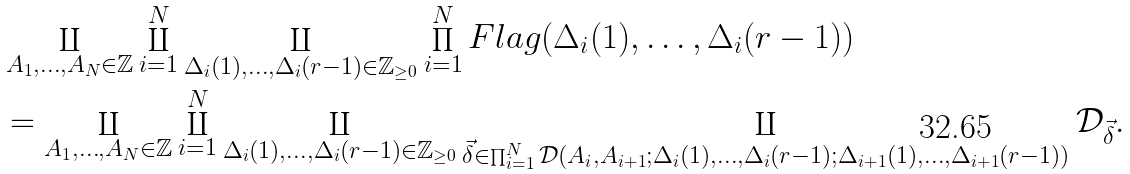<formula> <loc_0><loc_0><loc_500><loc_500>& \coprod _ { A _ { 1 } , \dots , A _ { N } \in \mathbb { Z } } \coprod _ { i = 1 } ^ { N } \coprod _ { \Delta _ { i } ( 1 ) , \dots , \Delta _ { i } ( r - 1 ) \in \mathbb { Z } _ { \geq 0 } } \prod _ { i = 1 } ^ { N } F l a g ( \Delta _ { i } ( 1 ) , \dots , \Delta _ { i } ( r - 1 ) ) \\ & = \coprod _ { A _ { 1 } , \dots , A _ { N } \in \mathbb { Z } } \coprod _ { i = 1 } ^ { N } \coprod _ { \Delta _ { i } ( 1 ) , \dots , \Delta _ { i } ( r - 1 ) \in \mathbb { Z } _ { \geq 0 } } \coprod _ { \vec { \delta } \in \prod _ { i = 1 } ^ { N } \mathcal { D } ( A _ { i } , A _ { i + 1 } ; \Delta _ { i } ( 1 ) , \dots , \Delta _ { i } ( r - 1 ) ; \Delta _ { i + 1 } ( 1 ) , \dots , \Delta _ { i + 1 } ( r - 1 ) ) } \mathcal { D } _ { \vec { \delta } } .</formula> 